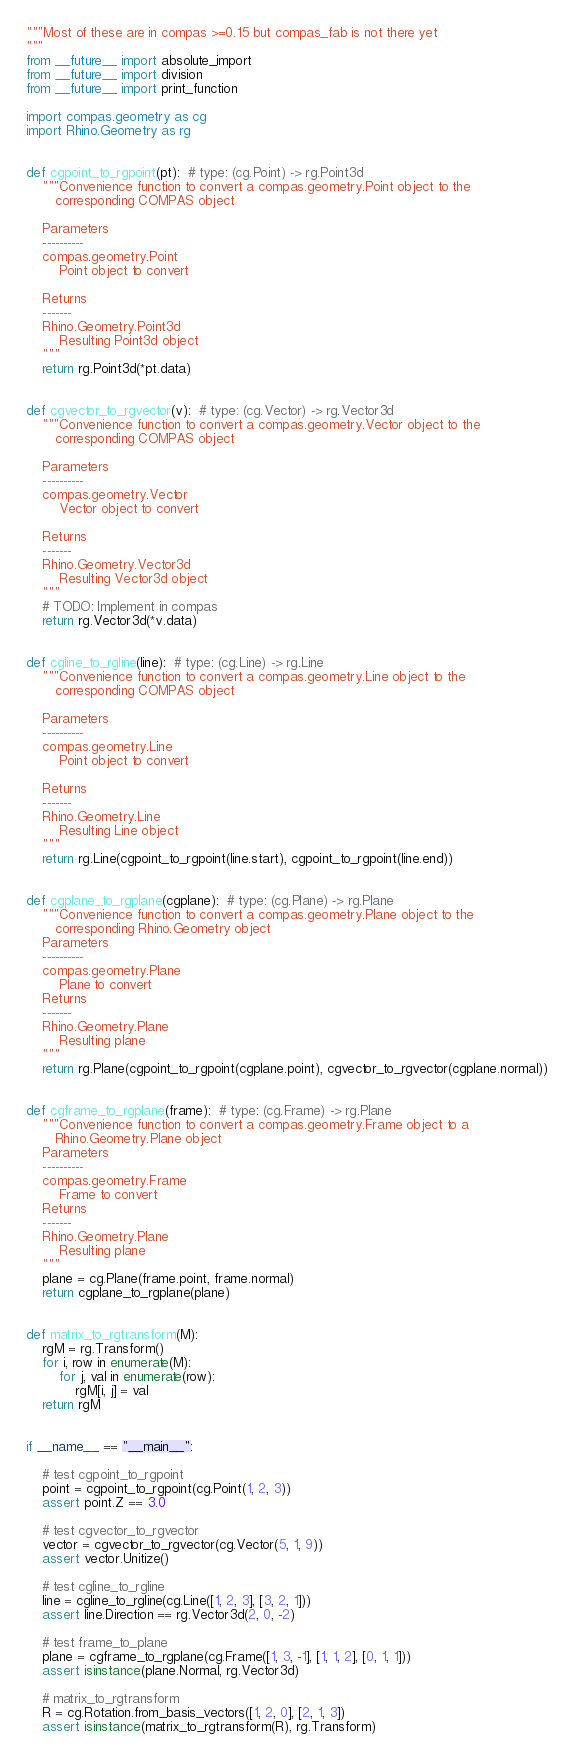<code> <loc_0><loc_0><loc_500><loc_500><_Python_>"""Most of these are in compas >=0.15 but compas_fab is not there yet
"""
from __future__ import absolute_import
from __future__ import division
from __future__ import print_function

import compas.geometry as cg
import Rhino.Geometry as rg


def cgpoint_to_rgpoint(pt):  # type: (cg.Point) -> rg.Point3d
    """Convenience function to convert a compas.geometry.Point object to the
       corresponding COMPAS object

    Parameters
    ----------
    compas.geometry.Point
        Point object to convert

    Returns
    -------
    Rhino.Geometry.Point3d
        Resulting Point3d object
    """
    return rg.Point3d(*pt.data)


def cgvector_to_rgvector(v):  # type: (cg.Vector) -> rg.Vector3d
    """Convenience function to convert a compas.geometry.Vector object to the
       corresponding COMPAS object

    Parameters
    ----------
    compas.geometry.Vector
        Vector object to convert

    Returns
    -------
    Rhino.Geometry.Vector3d
        Resulting Vector3d object
    """
    # TODO: Implement in compas
    return rg.Vector3d(*v.data)


def cgline_to_rgline(line):  # type: (cg.Line) -> rg.Line
    """Convenience function to convert a compas.geometry.Line object to the
       corresponding COMPAS object

    Parameters
    ----------
    compas.geometry.Line
        Point object to convert

    Returns
    -------
    Rhino.Geometry.Line
        Resulting Line object
    """
    return rg.Line(cgpoint_to_rgpoint(line.start), cgpoint_to_rgpoint(line.end))


def cgplane_to_rgplane(cgplane):  # type: (cg.Plane) -> rg.Plane
    """Convenience function to convert a compas.geometry.Plane object to the
       corresponding Rhino.Geometry object
    Parameters
    ----------
    compas.geometry.Plane
        Plane to convert
    Returns
    -------
    Rhino.Geometry.Plane
        Resulting plane
    """
    return rg.Plane(cgpoint_to_rgpoint(cgplane.point), cgvector_to_rgvector(cgplane.normal))


def cgframe_to_rgplane(frame):  # type: (cg.Frame) -> rg.Plane
    """Convenience function to convert a compas.geometry.Frame object to a
       Rhino.Geometry.Plane object
    Parameters
    ----------
    compas.geometry.Frame
        Frame to convert
    Returns
    -------
    Rhino.Geometry.Plane
        Resulting plane
    """
    plane = cg.Plane(frame.point, frame.normal)
    return cgplane_to_rgplane(plane)


def matrix_to_rgtransform(M):
    rgM = rg.Transform()
    for i, row in enumerate(M):
        for j, val in enumerate(row):
            rgM[i, j] = val
    return rgM


if __name__ == "__main__":

    # test cgpoint_to_rgpoint
    point = cgpoint_to_rgpoint(cg.Point(1, 2, 3))
    assert point.Z == 3.0

    # test cgvector_to_rgvector
    vector = cgvector_to_rgvector(cg.Vector(5, 1, 9))
    assert vector.Unitize()

    # test cgline_to_rgline
    line = cgline_to_rgline(cg.Line([1, 2, 3], [3, 2, 1]))
    assert line.Direction == rg.Vector3d(2, 0, -2)

    # test frame_to_plane
    plane = cgframe_to_rgplane(cg.Frame([1, 3, -1], [1, 1, 2], [0, 1, 1]))
    assert isinstance(plane.Normal, rg.Vector3d)

    # matrix_to_rgtransform
    R = cg.Rotation.from_basis_vectors([1, 2, 0], [2, 1, 3])
    assert isinstance(matrix_to_rgtransform(R), rg.Transform)
</code> 